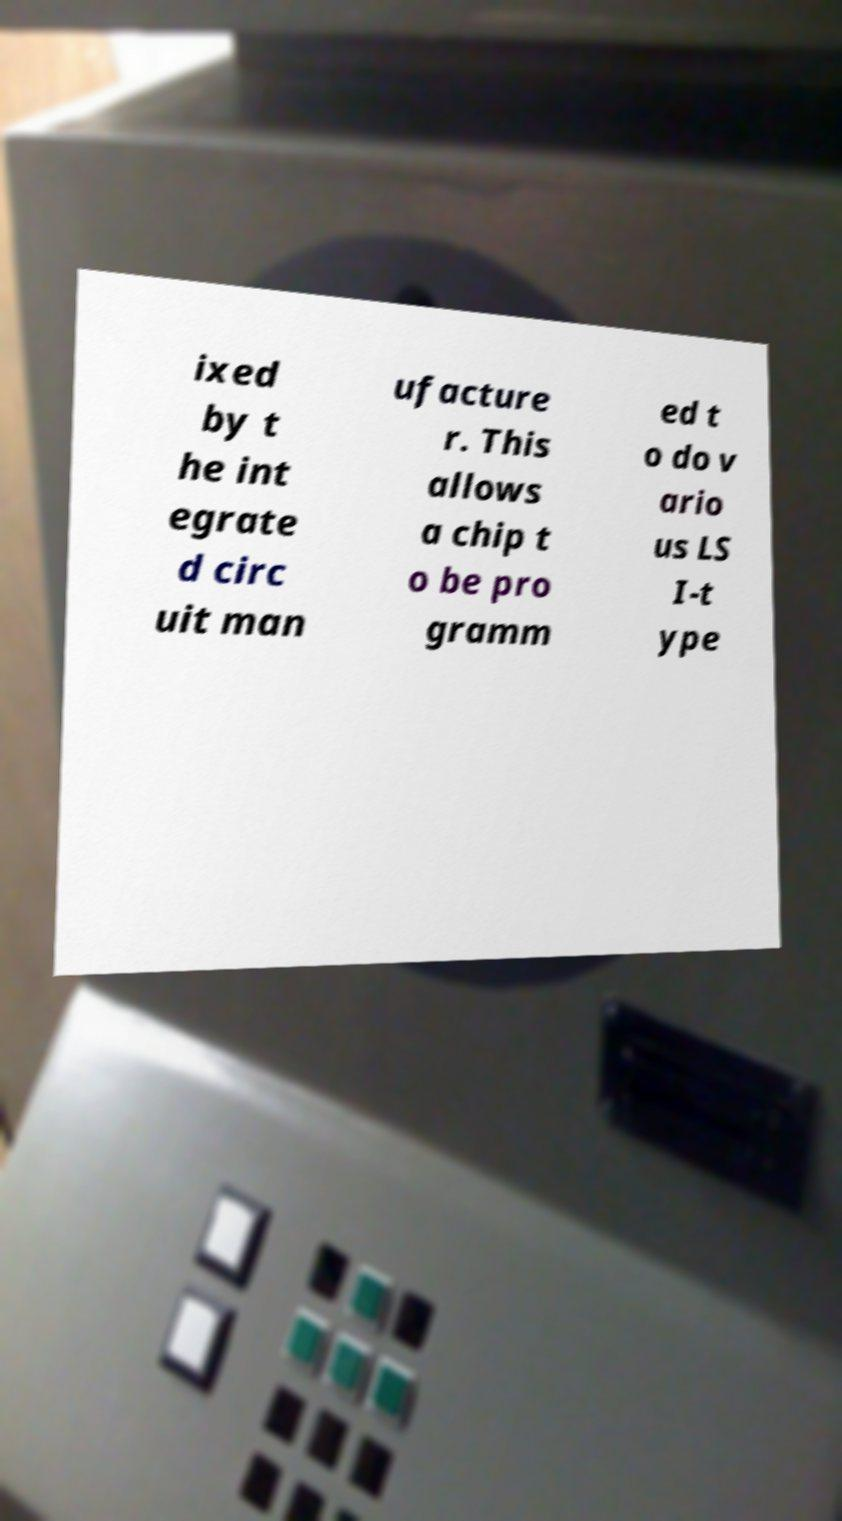Could you assist in decoding the text presented in this image and type it out clearly? ixed by t he int egrate d circ uit man ufacture r. This allows a chip t o be pro gramm ed t o do v ario us LS I-t ype 